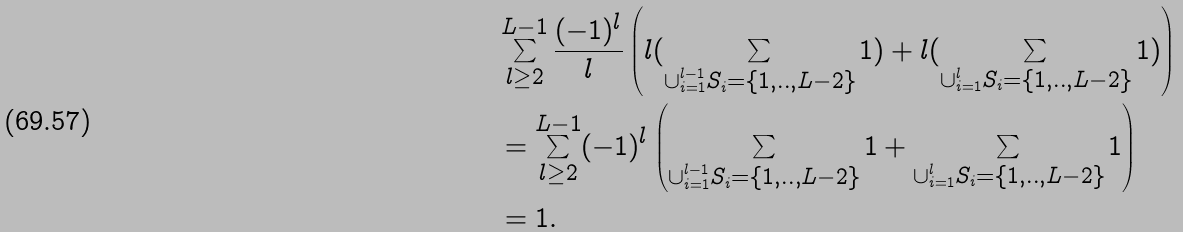Convert formula to latex. <formula><loc_0><loc_0><loc_500><loc_500>& \sum _ { l \geq 2 } ^ { L - 1 } \frac { ( - 1 ) ^ { l } } { l } \left ( l ( \sum _ { \cup _ { i = 1 } ^ { l - 1 } S _ { i } = \{ 1 , . . , L - 2 \} } 1 ) + l ( \sum _ { \cup _ { i = 1 } ^ { l } S _ { i } = \{ 1 , . . , L - 2 \} } 1 ) \right ) \\ & = \sum _ { l \geq 2 } ^ { L - 1 } ( - 1 ) ^ { l } \left ( \sum _ { \cup _ { i = 1 } ^ { l - 1 } S _ { i } = \{ 1 , . . , L - 2 \} } 1 + \sum _ { \cup _ { i = 1 } ^ { l } S _ { i } = \{ 1 , . . , L - 2 \} } 1 \right ) \\ & = 1 .</formula> 